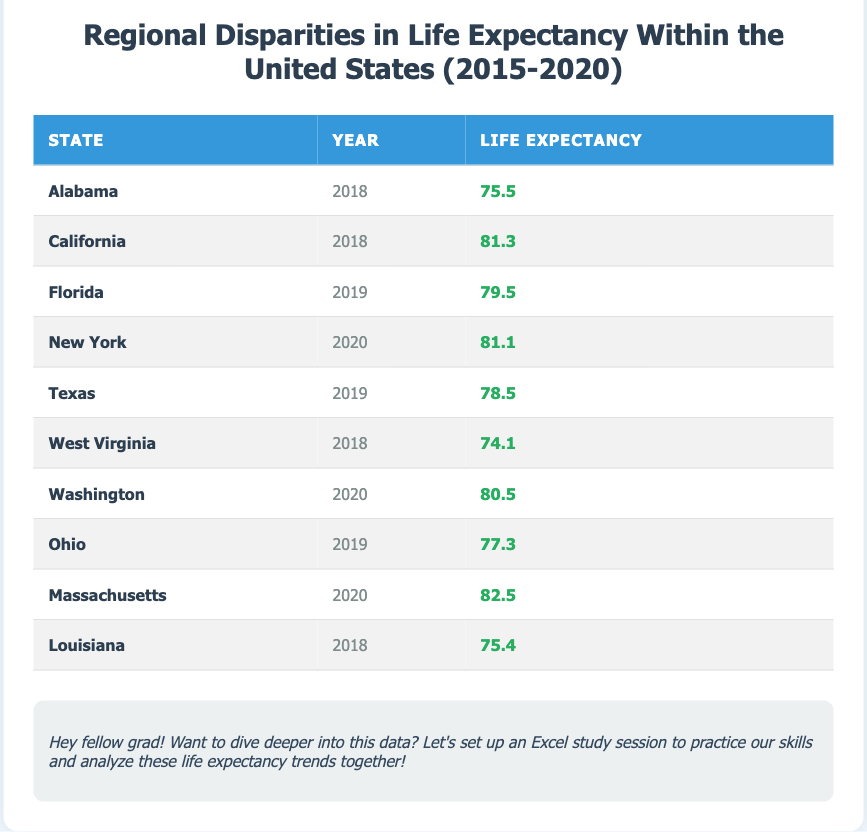What is the life expectancy of Alabama in 2018? The table shows that the life expectancy for Alabama in the year 2018 is listed as 75.5.
Answer: 75.5 Which state had the highest life expectancy in 2020? By comparing the life expectancy values for the year 2020, New York has a life expectancy of 81.1, while Massachusetts has a higher life expectancy of 82.5. Therefore, Massachusetts had the highest life expectancy in 2020.
Answer: Massachusetts What is the average life expectancy of the states listed for 2018? To find the average life expectancy for 2018, we sum the life expectancies for Alabama (75.5), California (81.3), Louisiana (75.4), and West Virginia (74.1) which equals (75.5 + 81.3 + 75.4 + 74.1) = 306.3. There are 4 data points, so the average is 306.3/4 = 76.575.
Answer: 76.575 Is the life expectancy of Texas greater than 75? The life expectancy for Texas in 2019 is 78.5, which is indeed greater than 75.
Answer: Yes Which two states had the lowest life expectancy in 2018? The table indicates that Alabama had a life expectancy of 75.5 and West Virginia had the lowest life expectancy of 74.1 for the year 2018. Therefore, the lowest were Alabama and West Virginia.
Answer: Alabama and West Virginia What is the difference in life expectancy between Massachusetts in 2020 and West Virginia in 2018? The life expectancy for Massachusetts in 2020 is 82.5, while for West Virginia in 2018 it is 74.1. The difference in life expectancy is calculated as 82.5 - 74.1 = 8.4.
Answer: 8.4 Is it true that Florida's life expectancy is less than Ohio's in 2019? Looking at the data, Florida's life expectancy for 2019 is 79.5, while Ohio's life expectancy is 77.3. Therefore, it is false that Florida’s life expectancy is less than Ohio’s.
Answer: No What year had the life expectancy of California, and what was that value? California's life expectancy was recorded in 2018, and the value is 81.3.
Answer: 2018, 81.3 How many states had a life expectancy of more than 80 between 2018 and 2020? From the table, Massachusetts (82.5), California (81.3), and New York (81.1) are the only states with a life expectancy greater than 80 in the years provided. Therefore, there are three states with a life expectancy over 80.
Answer: 3 